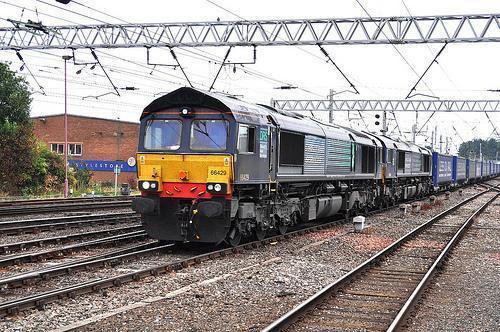How many trains can be seen?
Give a very brief answer. 1. 